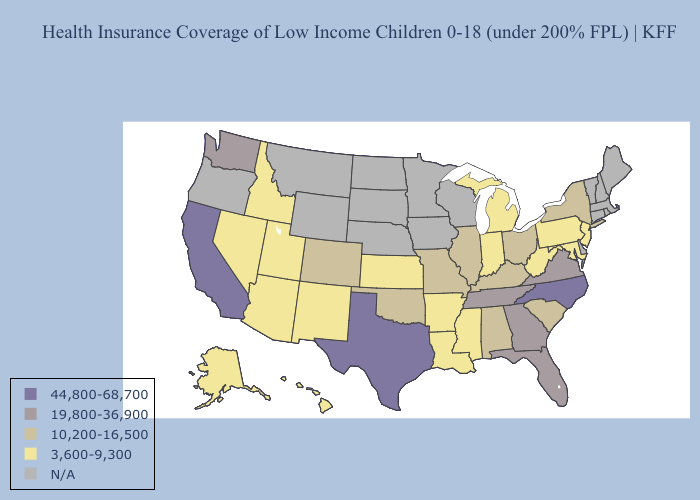What is the value of Missouri?
Short answer required. 10,200-16,500. What is the lowest value in the USA?
Keep it brief. 3,600-9,300. What is the lowest value in the Northeast?
Quick response, please. 3,600-9,300. What is the value of Colorado?
Write a very short answer. 10,200-16,500. What is the highest value in the Northeast ?
Write a very short answer. 10,200-16,500. What is the highest value in the USA?
Give a very brief answer. 44,800-68,700. What is the lowest value in states that border Oklahoma?
Concise answer only. 3,600-9,300. What is the lowest value in the Northeast?
Be succinct. 3,600-9,300. What is the value of Idaho?
Keep it brief. 3,600-9,300. What is the value of Mississippi?
Be succinct. 3,600-9,300. What is the value of Massachusetts?
Answer briefly. N/A. Does Texas have the lowest value in the South?
Give a very brief answer. No. What is the lowest value in states that border California?
Answer briefly. 3,600-9,300. Name the states that have a value in the range 10,200-16,500?
Keep it brief. Alabama, Colorado, Illinois, Kentucky, Missouri, New York, Ohio, Oklahoma, South Carolina. 